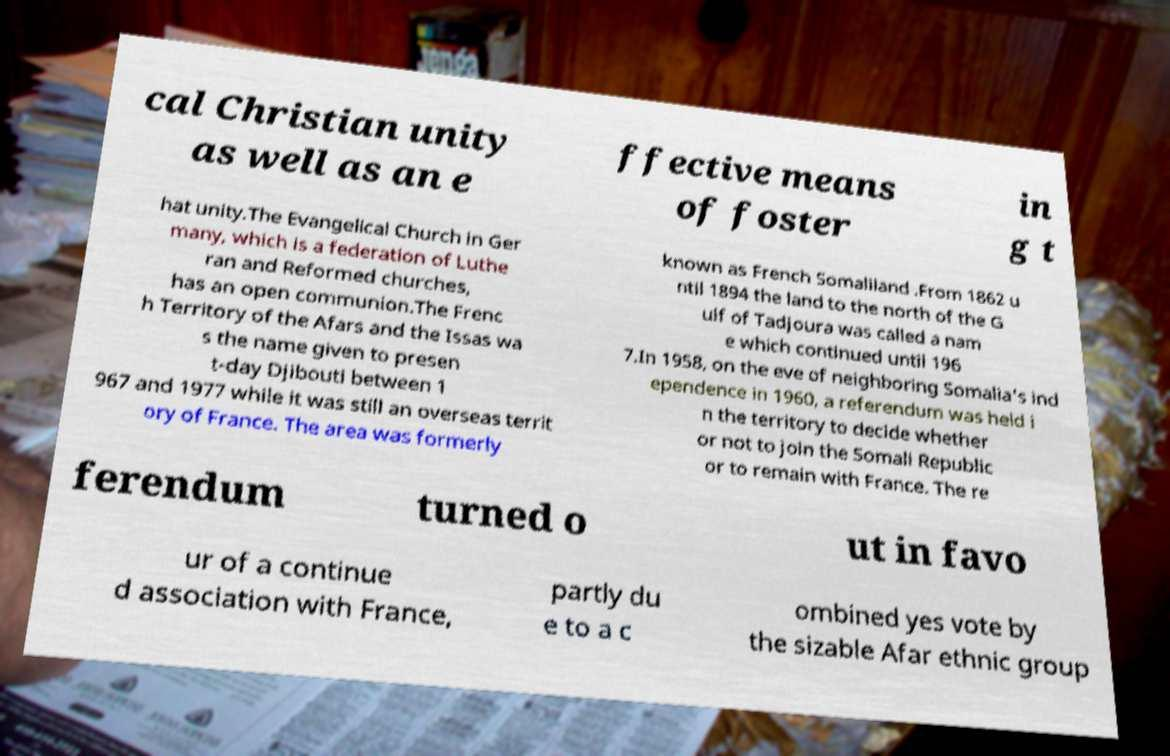Could you assist in decoding the text presented in this image and type it out clearly? cal Christian unity as well as an e ffective means of foster in g t hat unity.The Evangelical Church in Ger many, which is a federation of Luthe ran and Reformed churches, has an open communion.The Frenc h Territory of the Afars and the Issas wa s the name given to presen t-day Djibouti between 1 967 and 1977 while it was still an overseas territ ory of France. The area was formerly known as French Somaliland .From 1862 u ntil 1894 the land to the north of the G ulf of Tadjoura was called a nam e which continued until 196 7.In 1958, on the eve of neighboring Somalia's ind ependence in 1960, a referendum was held i n the territory to decide whether or not to join the Somali Republic or to remain with France. The re ferendum turned o ut in favo ur of a continue d association with France, partly du e to a c ombined yes vote by the sizable Afar ethnic group 